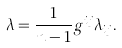<formula> <loc_0><loc_0><loc_500><loc_500>\lambda = \frac { 1 } { n - 1 } g ^ { i j } \lambda _ { i j } .</formula> 